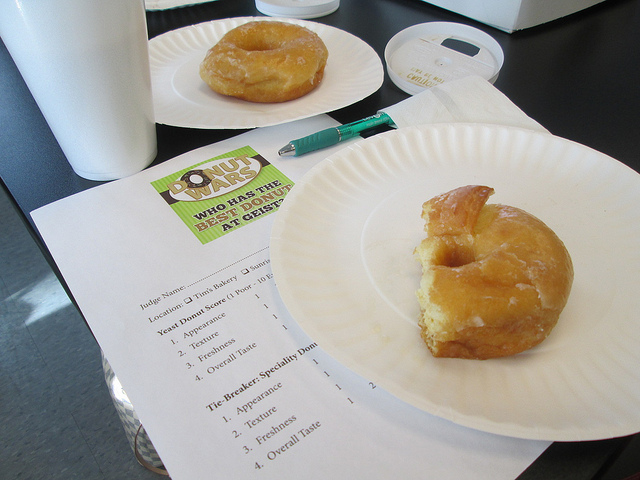<image>What kind of magazines are on the table? There are no magazines on the table. The items could be a menu or a survey. What kind of magazines are on the table? There are no magazines on the table in the image. 